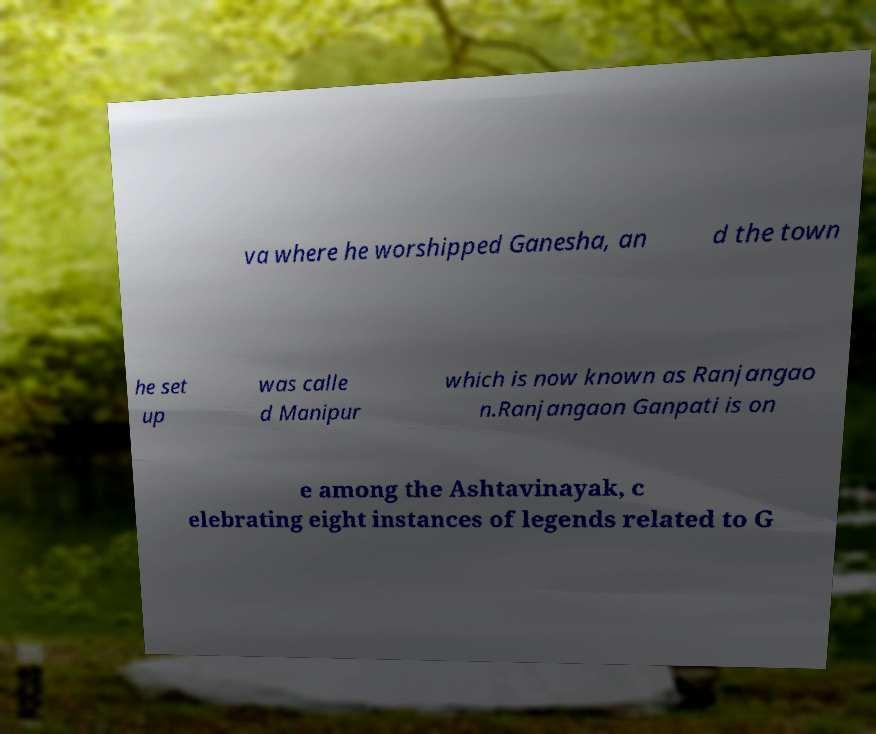Could you extract and type out the text from this image? va where he worshipped Ganesha, an d the town he set up was calle d Manipur which is now known as Ranjangao n.Ranjangaon Ganpati is on e among the Ashtavinayak, c elebrating eight instances of legends related to G 